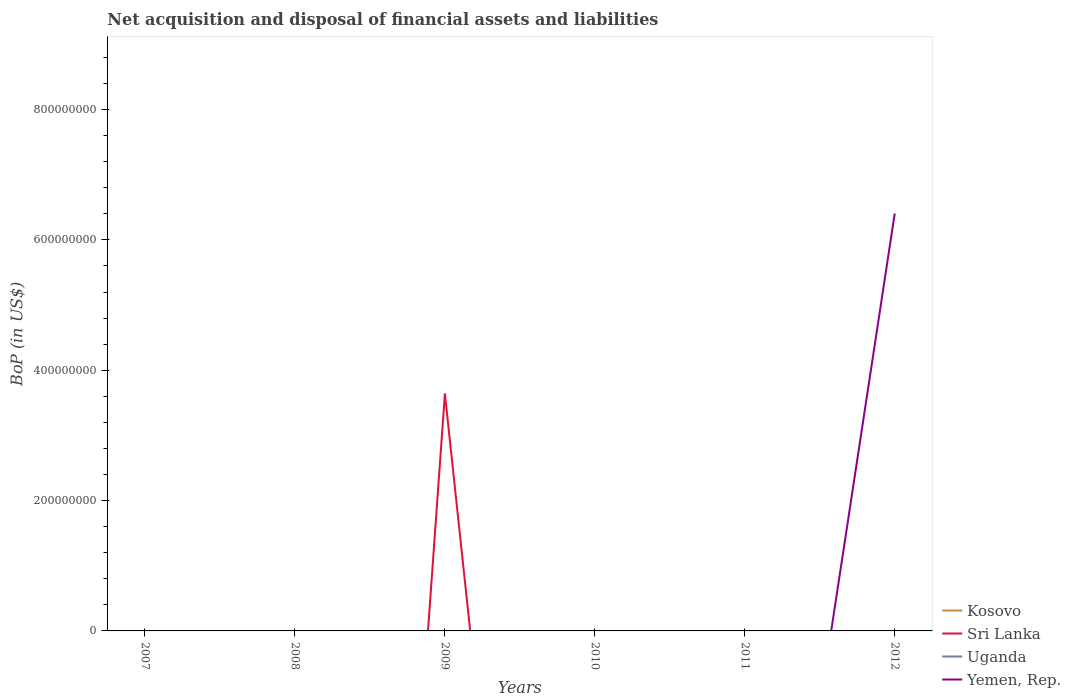How many different coloured lines are there?
Your response must be concise. 2. Across all years, what is the maximum Balance of Payments in Uganda?
Your answer should be compact. 0. What is the difference between the highest and the second highest Balance of Payments in Yemen, Rep.?
Make the answer very short. 6.41e+08. Is the Balance of Payments in Kosovo strictly greater than the Balance of Payments in Sri Lanka over the years?
Your answer should be very brief. No. How many lines are there?
Give a very brief answer. 2. What is the difference between two consecutive major ticks on the Y-axis?
Give a very brief answer. 2.00e+08. Are the values on the major ticks of Y-axis written in scientific E-notation?
Give a very brief answer. No. Does the graph contain grids?
Make the answer very short. No. How are the legend labels stacked?
Provide a short and direct response. Vertical. What is the title of the graph?
Your response must be concise. Net acquisition and disposal of financial assets and liabilities. What is the label or title of the X-axis?
Your response must be concise. Years. What is the label or title of the Y-axis?
Your answer should be compact. BoP (in US$). What is the BoP (in US$) of Uganda in 2007?
Ensure brevity in your answer.  0. What is the BoP (in US$) of Kosovo in 2008?
Your answer should be compact. 0. What is the BoP (in US$) of Sri Lanka in 2008?
Give a very brief answer. 0. What is the BoP (in US$) in Uganda in 2008?
Offer a terse response. 0. What is the BoP (in US$) in Kosovo in 2009?
Provide a short and direct response. 0. What is the BoP (in US$) of Sri Lanka in 2009?
Your answer should be compact. 3.64e+08. What is the BoP (in US$) in Uganda in 2009?
Your response must be concise. 0. What is the BoP (in US$) in Kosovo in 2010?
Offer a very short reply. 0. What is the BoP (in US$) in Sri Lanka in 2010?
Offer a terse response. 0. What is the BoP (in US$) of Uganda in 2010?
Your response must be concise. 0. What is the BoP (in US$) of Uganda in 2011?
Make the answer very short. 0. What is the BoP (in US$) of Yemen, Rep. in 2011?
Your answer should be compact. 0. What is the BoP (in US$) in Kosovo in 2012?
Your answer should be very brief. 0. What is the BoP (in US$) of Sri Lanka in 2012?
Give a very brief answer. 0. What is the BoP (in US$) of Uganda in 2012?
Keep it short and to the point. 0. What is the BoP (in US$) of Yemen, Rep. in 2012?
Offer a very short reply. 6.41e+08. Across all years, what is the maximum BoP (in US$) of Sri Lanka?
Your answer should be compact. 3.64e+08. Across all years, what is the maximum BoP (in US$) in Yemen, Rep.?
Offer a terse response. 6.41e+08. Across all years, what is the minimum BoP (in US$) of Sri Lanka?
Keep it short and to the point. 0. Across all years, what is the minimum BoP (in US$) in Yemen, Rep.?
Ensure brevity in your answer.  0. What is the total BoP (in US$) of Kosovo in the graph?
Provide a short and direct response. 0. What is the total BoP (in US$) of Sri Lanka in the graph?
Offer a terse response. 3.64e+08. What is the total BoP (in US$) of Yemen, Rep. in the graph?
Make the answer very short. 6.41e+08. What is the difference between the BoP (in US$) of Sri Lanka in 2009 and the BoP (in US$) of Yemen, Rep. in 2012?
Give a very brief answer. -2.77e+08. What is the average BoP (in US$) of Kosovo per year?
Provide a short and direct response. 0. What is the average BoP (in US$) of Sri Lanka per year?
Give a very brief answer. 6.07e+07. What is the average BoP (in US$) of Uganda per year?
Your answer should be compact. 0. What is the average BoP (in US$) of Yemen, Rep. per year?
Your answer should be compact. 1.07e+08. What is the difference between the highest and the lowest BoP (in US$) of Sri Lanka?
Offer a very short reply. 3.64e+08. What is the difference between the highest and the lowest BoP (in US$) in Yemen, Rep.?
Offer a terse response. 6.41e+08. 